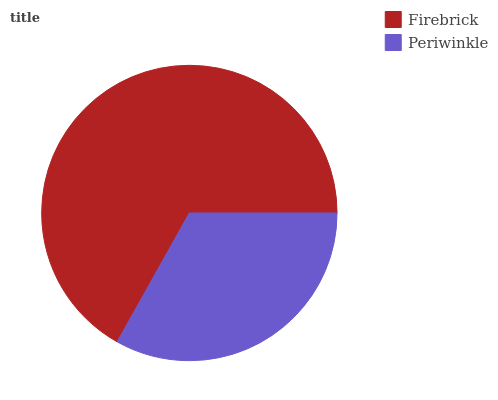Is Periwinkle the minimum?
Answer yes or no. Yes. Is Firebrick the maximum?
Answer yes or no. Yes. Is Periwinkle the maximum?
Answer yes or no. No. Is Firebrick greater than Periwinkle?
Answer yes or no. Yes. Is Periwinkle less than Firebrick?
Answer yes or no. Yes. Is Periwinkle greater than Firebrick?
Answer yes or no. No. Is Firebrick less than Periwinkle?
Answer yes or no. No. Is Firebrick the high median?
Answer yes or no. Yes. Is Periwinkle the low median?
Answer yes or no. Yes. Is Periwinkle the high median?
Answer yes or no. No. Is Firebrick the low median?
Answer yes or no. No. 